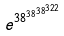Convert formula to latex. <formula><loc_0><loc_0><loc_500><loc_500>e ^ { 3 8 ^ { 3 8 ^ { 3 8 ^ { 3 2 2 } } } }</formula> 